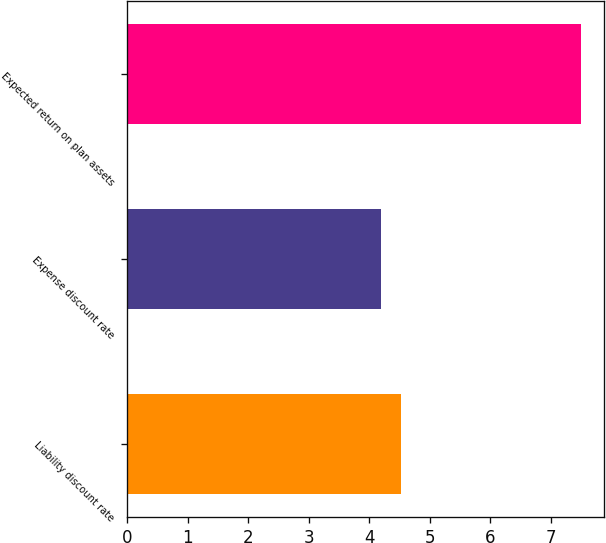Convert chart to OTSL. <chart><loc_0><loc_0><loc_500><loc_500><bar_chart><fcel>Liability discount rate<fcel>Expense discount rate<fcel>Expected return on plan assets<nl><fcel>4.53<fcel>4.2<fcel>7.5<nl></chart> 